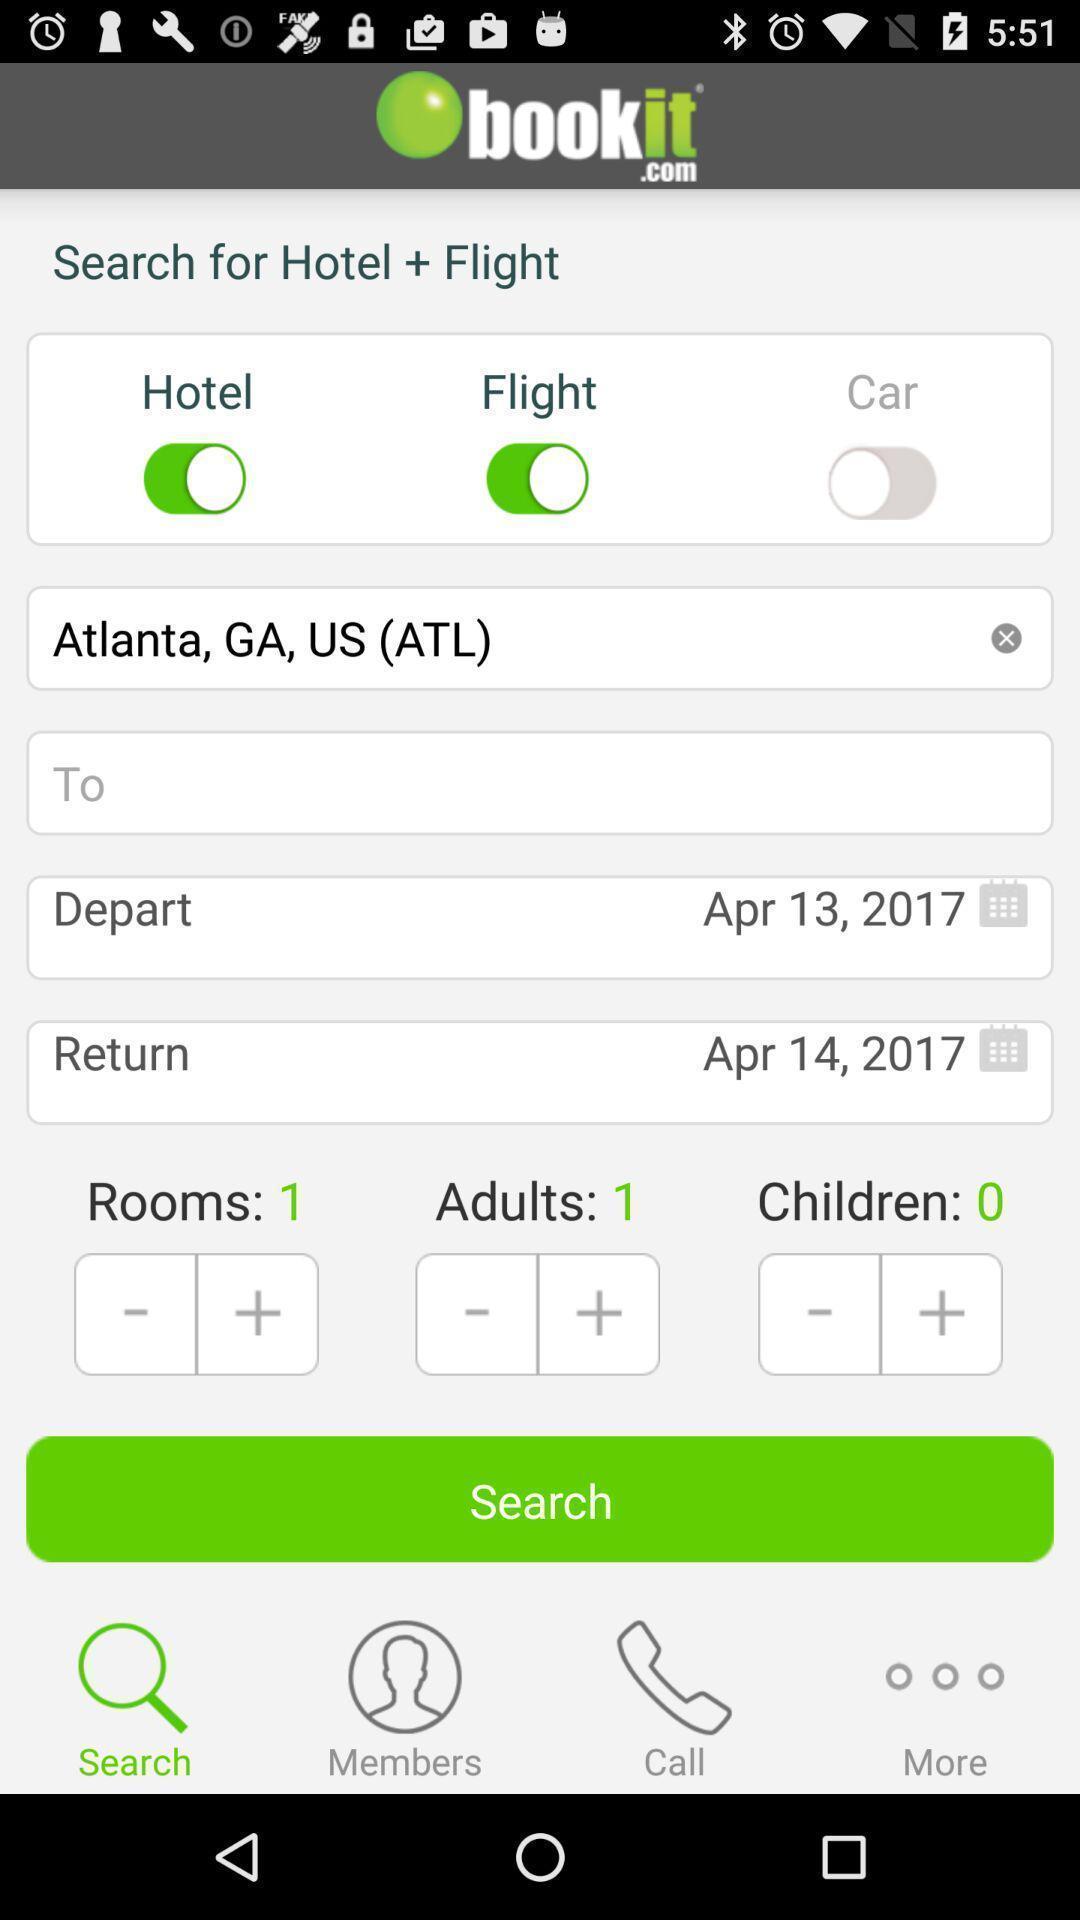What can you discern from this picture? Search page for hotels and flights on booking app. 